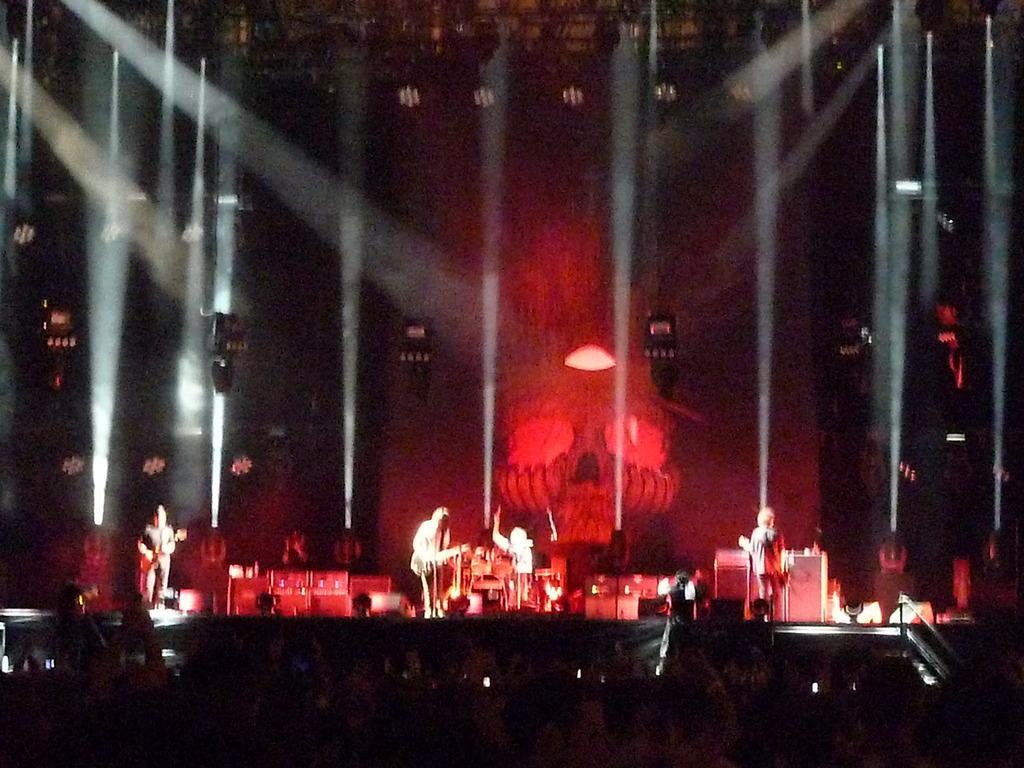How would you summarize this image in a sentence or two? This image is taken in the dark and this is a musical concert and this is a completely blurry image. I can see some lights and some people holding musical instruments on stage.  